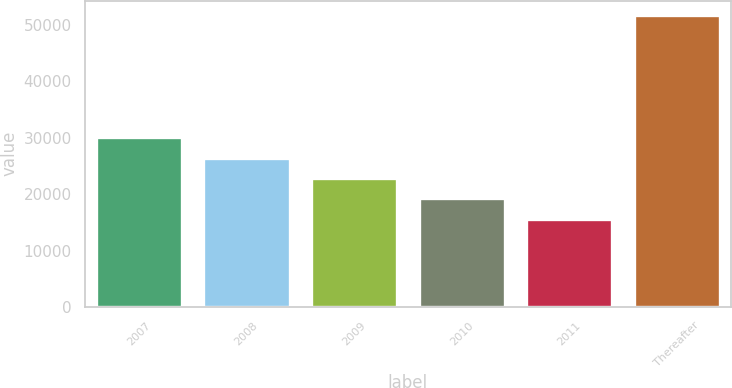Convert chart. <chart><loc_0><loc_0><loc_500><loc_500><bar_chart><fcel>2007<fcel>2008<fcel>2009<fcel>2010<fcel>2011<fcel>Thereafter<nl><fcel>30087.8<fcel>26477.1<fcel>22866.4<fcel>19255.7<fcel>15645<fcel>51752<nl></chart> 